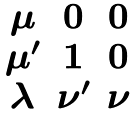<formula> <loc_0><loc_0><loc_500><loc_500>\begin{matrix} \mu & 0 & 0 \\ \mu ^ { \prime } & 1 & 0 \\ \lambda & \nu ^ { \prime } & \nu \end{matrix}</formula> 